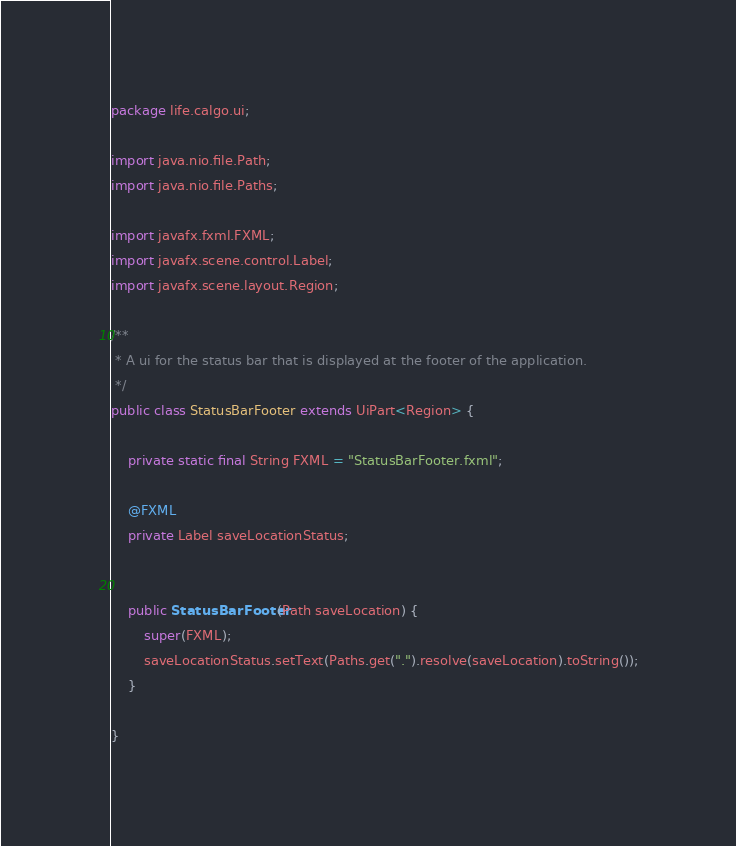<code> <loc_0><loc_0><loc_500><loc_500><_Java_>package life.calgo.ui;

import java.nio.file.Path;
import java.nio.file.Paths;

import javafx.fxml.FXML;
import javafx.scene.control.Label;
import javafx.scene.layout.Region;

/**
 * A ui for the status bar that is displayed at the footer of the application.
 */
public class StatusBarFooter extends UiPart<Region> {

    private static final String FXML = "StatusBarFooter.fxml";

    @FXML
    private Label saveLocationStatus;


    public StatusBarFooter(Path saveLocation) {
        super(FXML);
        saveLocationStatus.setText(Paths.get(".").resolve(saveLocation).toString());
    }

}
</code> 